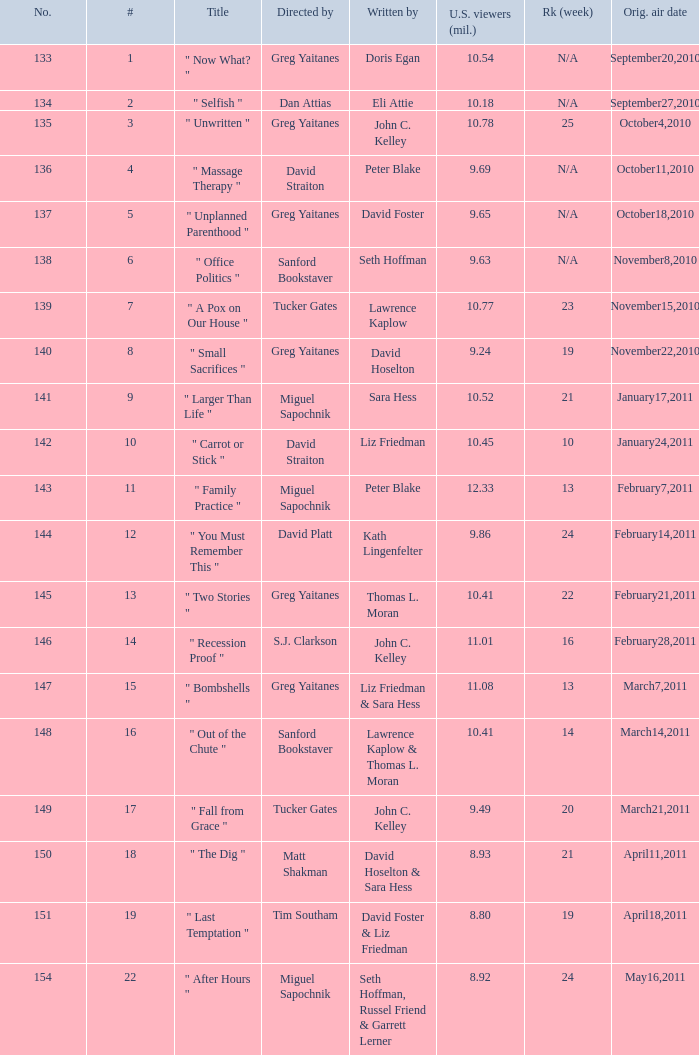Where did the episode rank that was written by thomas l. moran? 22.0. 